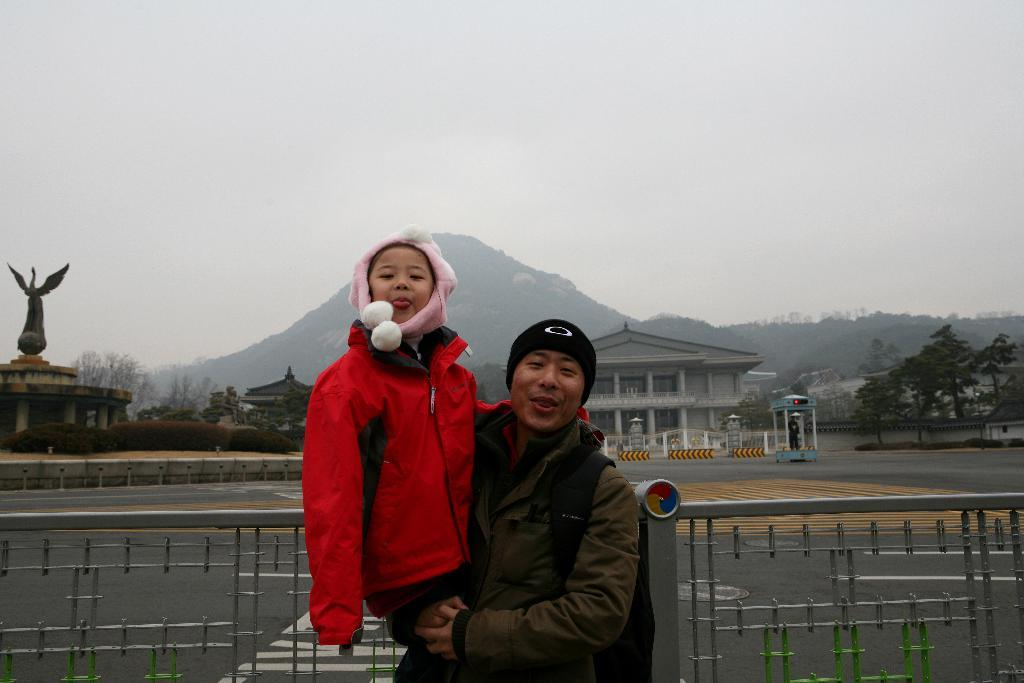How many people are present in the image? There are two persons in the image. What is one person doing with the baby? One person is carrying a baby. What type of landscape feature can be seen in the image? There is a hill in the image. What type of structures are visible in the image? There are many buildings in the image. What type of vegetation is present in the image? There are many trees in the image. What type of pathway is visible in the image? There is a road in the image. Where is the goat located in the image? There is no goat present in the image. What type of vehicle can be seen driving on the road in the image? There is no vehicle visible in the image; only a road is present. 